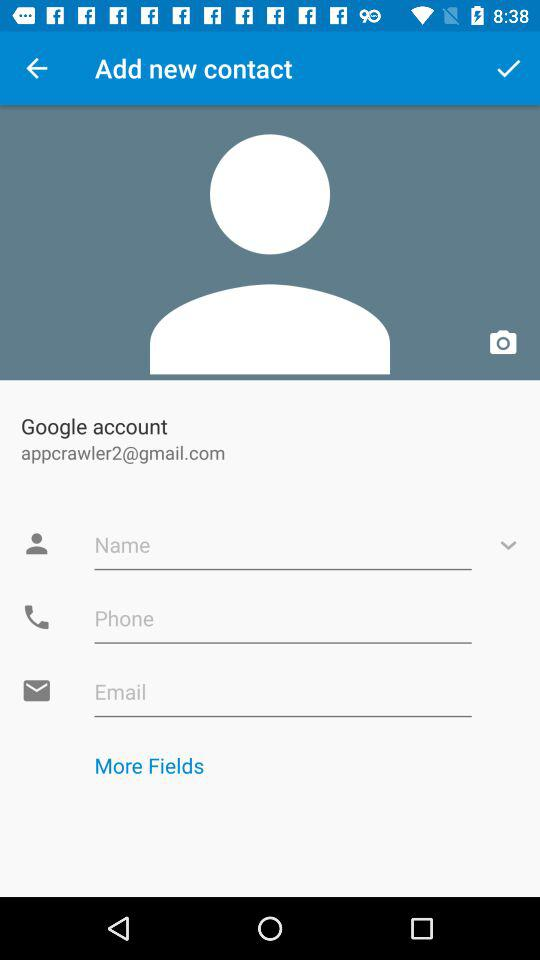How many input fields are there for contact information?
Answer the question using a single word or phrase. 3 